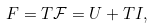<formula> <loc_0><loc_0><loc_500><loc_500>F = T \mathcal { F } = U + T I ,</formula> 